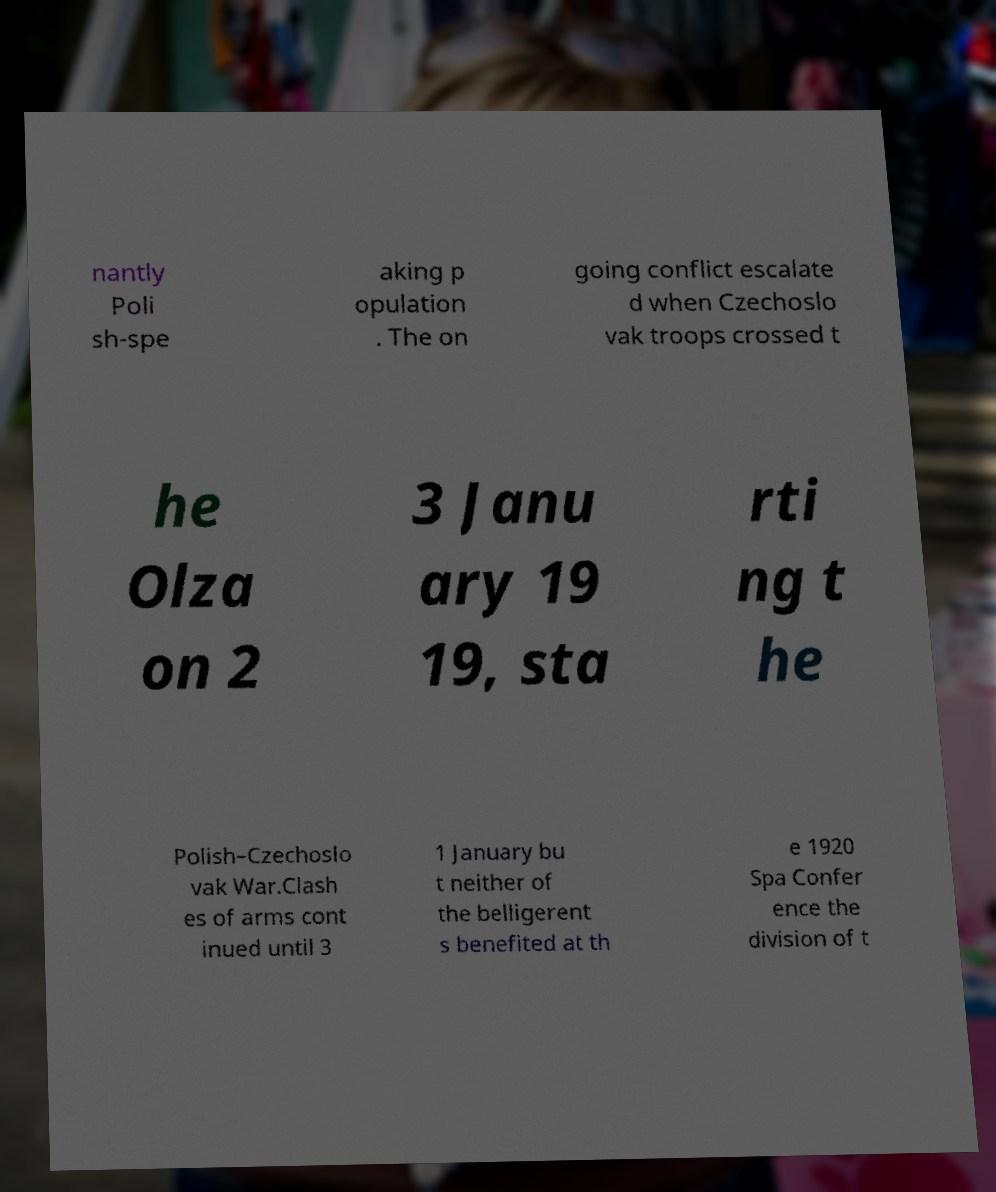I need the written content from this picture converted into text. Can you do that? nantly Poli sh-spe aking p opulation . The on going conflict escalate d when Czechoslo vak troops crossed t he Olza on 2 3 Janu ary 19 19, sta rti ng t he Polish–Czechoslo vak War.Clash es of arms cont inued until 3 1 January bu t neither of the belligerent s benefited at th e 1920 Spa Confer ence the division of t 